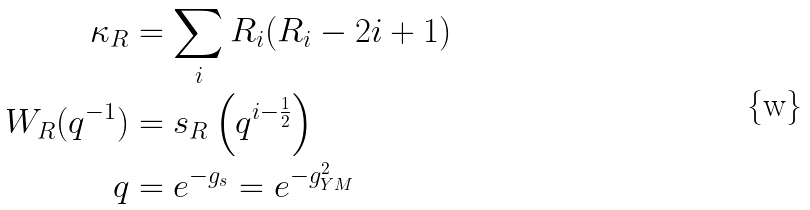Convert formula to latex. <formula><loc_0><loc_0><loc_500><loc_500>\kappa _ { R } & = \sum _ { i } R _ { i } ( R _ { i } - 2 i + 1 ) \\ W _ { R } ( q ^ { - 1 } ) & = s _ { R } \left ( q ^ { i - \frac { 1 } { 2 } } \right ) \\ q & = e ^ { - g _ { s } } = e ^ { - g _ { Y M } ^ { 2 } }</formula> 